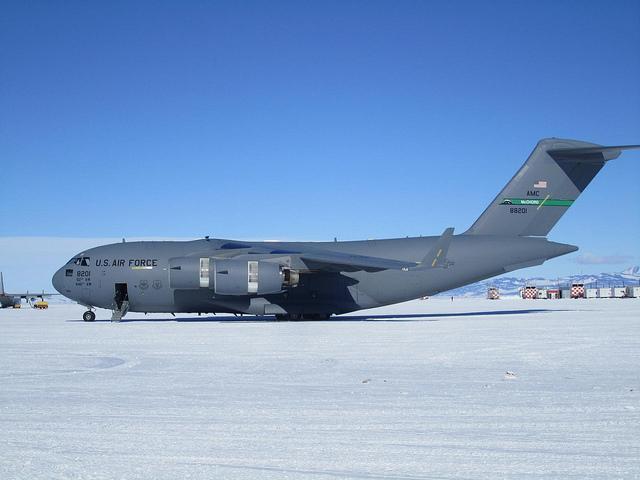The plane is most likely dropping off what to the people?
Select the accurate answer and provide explanation: 'Answer: answer
Rationale: rationale.'
Options: Weaponized vehicles, money, furniture, supplies. Answer: supplies.
Rationale: The plane is dropping off supplies. 